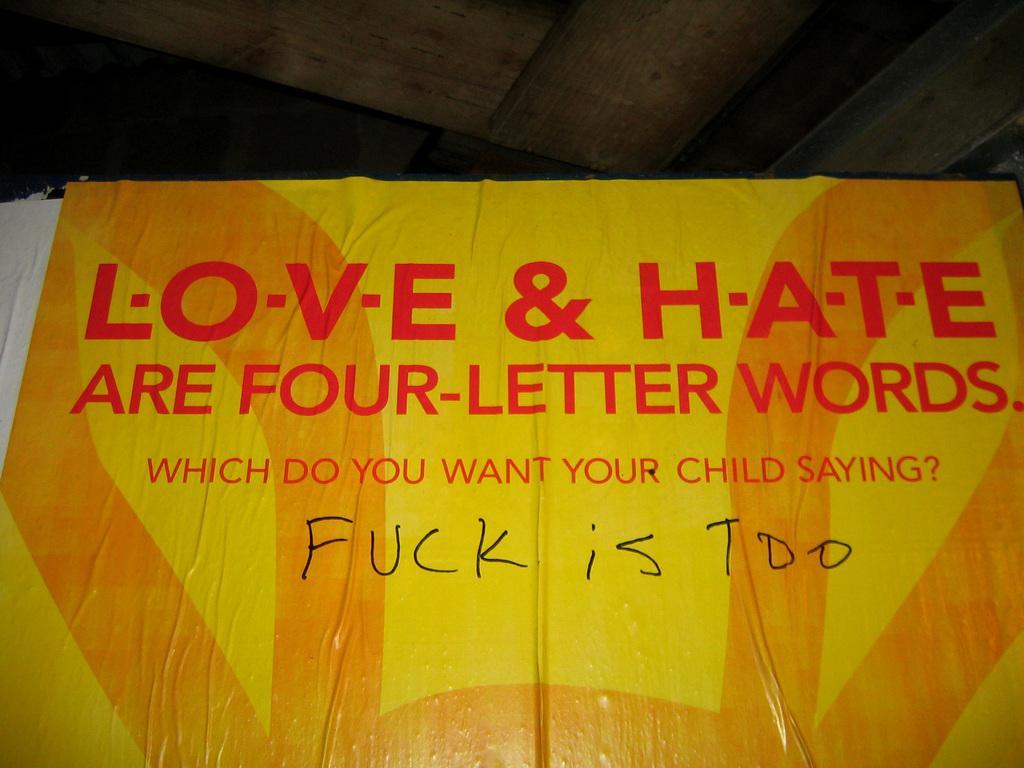Please provide a concise description of this image. In this image we can see a banner with text in the foreground. And there is a roof. 